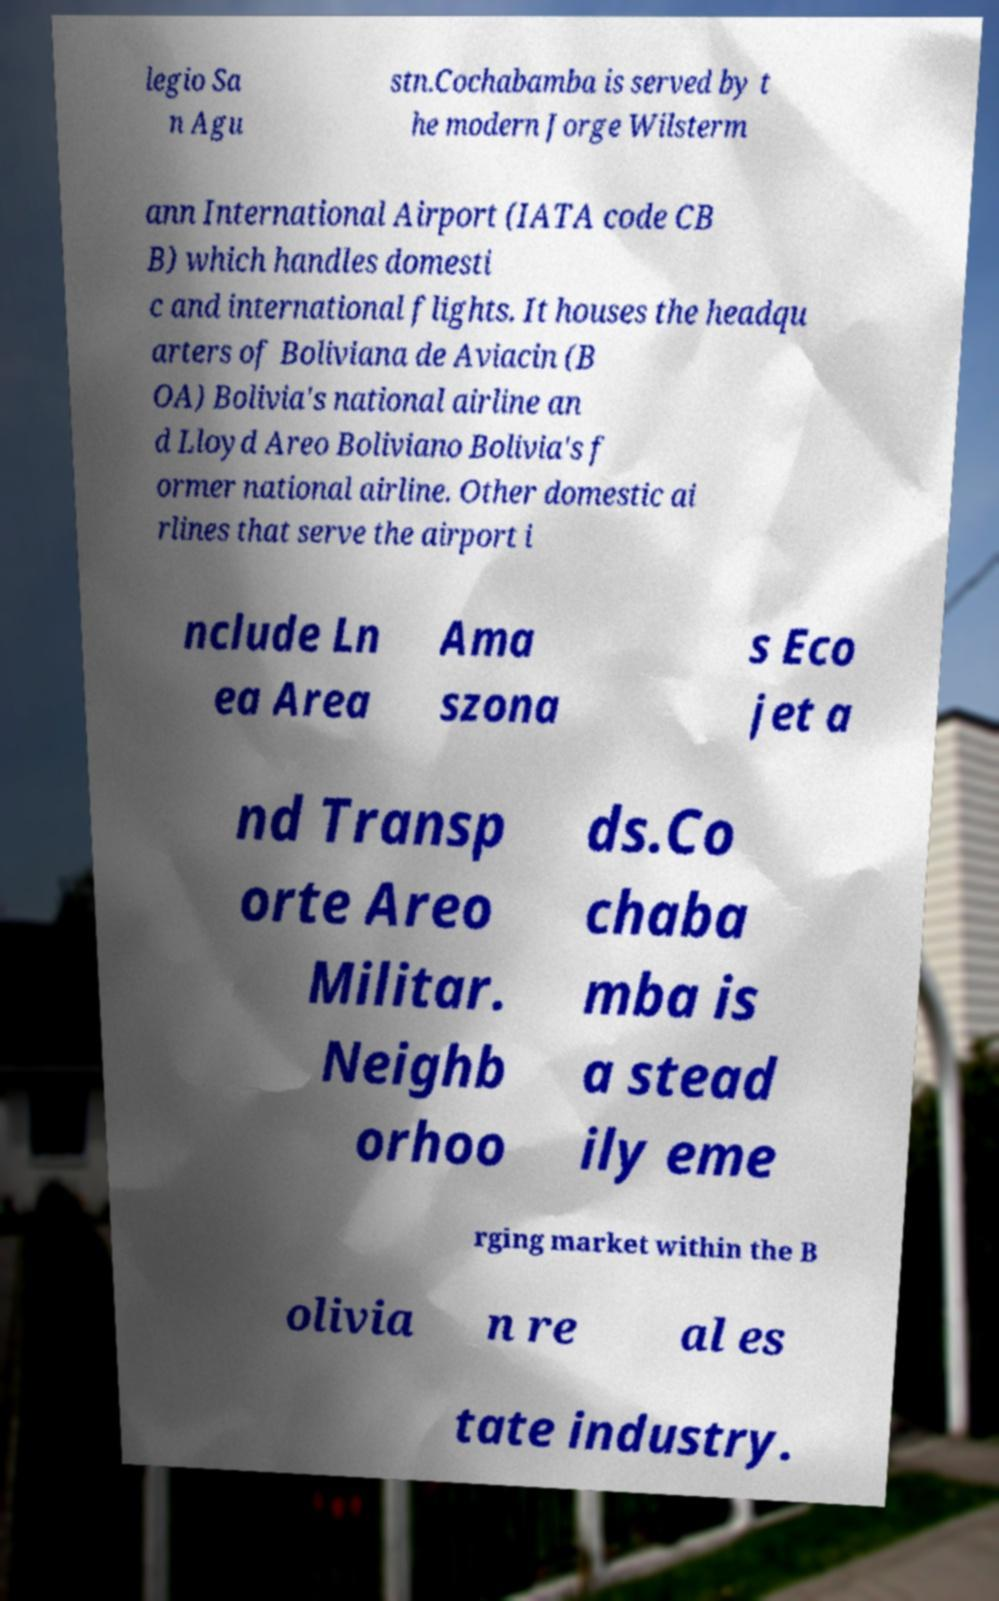Could you assist in decoding the text presented in this image and type it out clearly? legio Sa n Agu stn.Cochabamba is served by t he modern Jorge Wilsterm ann International Airport (IATA code CB B) which handles domesti c and international flights. It houses the headqu arters of Boliviana de Aviacin (B OA) Bolivia's national airline an d Lloyd Areo Boliviano Bolivia's f ormer national airline. Other domestic ai rlines that serve the airport i nclude Ln ea Area Ama szona s Eco jet a nd Transp orte Areo Militar. Neighb orhoo ds.Co chaba mba is a stead ily eme rging market within the B olivia n re al es tate industry. 